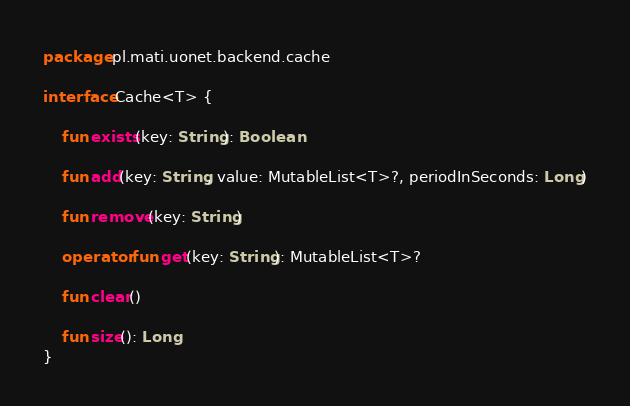Convert code to text. <code><loc_0><loc_0><loc_500><loc_500><_Kotlin_>package pl.mati.uonet.backend.cache

interface Cache<T> {

    fun exists(key: String): Boolean

    fun add(key: String, value: MutableList<T>?, periodInSeconds: Long)

    fun remove(key: String)

    operator fun get(key: String): MutableList<T>?

    fun clear()

    fun size(): Long
}
</code> 